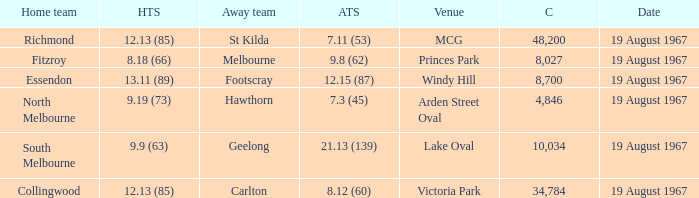When the venue was lake oval what did the home team score? 9.9 (63). 